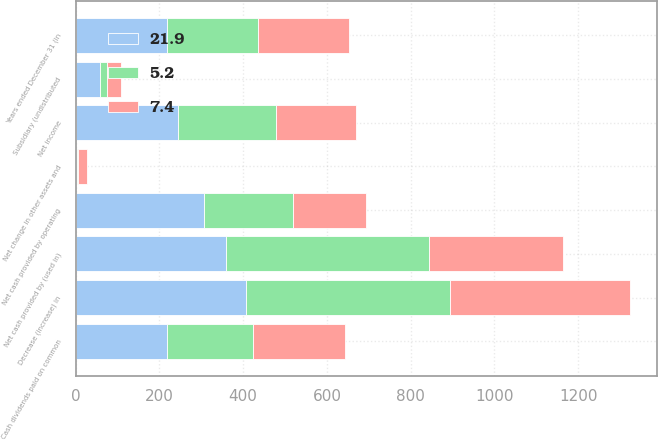Convert chart to OTSL. <chart><loc_0><loc_0><loc_500><loc_500><stacked_bar_chart><ecel><fcel>Years ended December 31 (in<fcel>Net income<fcel>Subsidiary (undistributed<fcel>Net change in other assets and<fcel>Net cash provided by operating<fcel>Decrease (increase) in<fcel>Net cash provided by (used in)<fcel>Cash dividends paid on common<nl><fcel>5.2<fcel>217.9<fcel>232.4<fcel>16.4<fcel>2.4<fcel>213.6<fcel>485<fcel>485<fcel>204.8<nl><fcel>21.9<fcel>217.9<fcel>245.3<fcel>58.3<fcel>2.2<fcel>305.8<fcel>408<fcel>358<fcel>217.9<nl><fcel>7.4<fcel>217.9<fcel>192.4<fcel>34<fcel>21.5<fcel>173.8<fcel>430<fcel>320.2<fcel>220.9<nl></chart> 